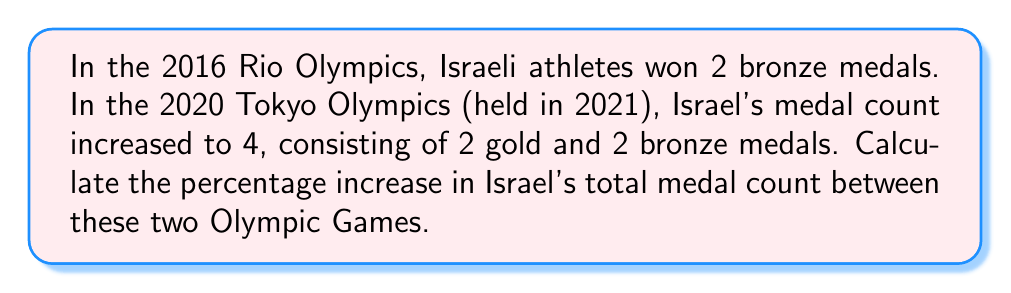Can you answer this question? Let's approach this step-by-step:

1. Identify the initial and final values:
   - Initial value (2016 Rio Olympics): 2 medals
   - Final value (2020 Tokyo Olympics): 4 medals

2. Calculate the increase in medals:
   $\text{Increase} = \text{Final value} - \text{Initial value}$
   $\text{Increase} = 4 - 2 = 2$ medals

3. Calculate the percentage increase:
   The formula for percentage increase is:
   $$\text{Percentage Increase} = \frac{\text{Increase}}{\text{Initial value}} \times 100\%$$

   Plugging in our values:
   $$\text{Percentage Increase} = \frac{2}{2} \times 100\%$$

4. Simplify the fraction:
   $$\text{Percentage Increase} = 1 \times 100\% = 100\%$$

Therefore, the percentage increase in Israel's medal count between the 2016 Rio Olympics and the 2020 Tokyo Olympics was 100%.
Answer: 100% 